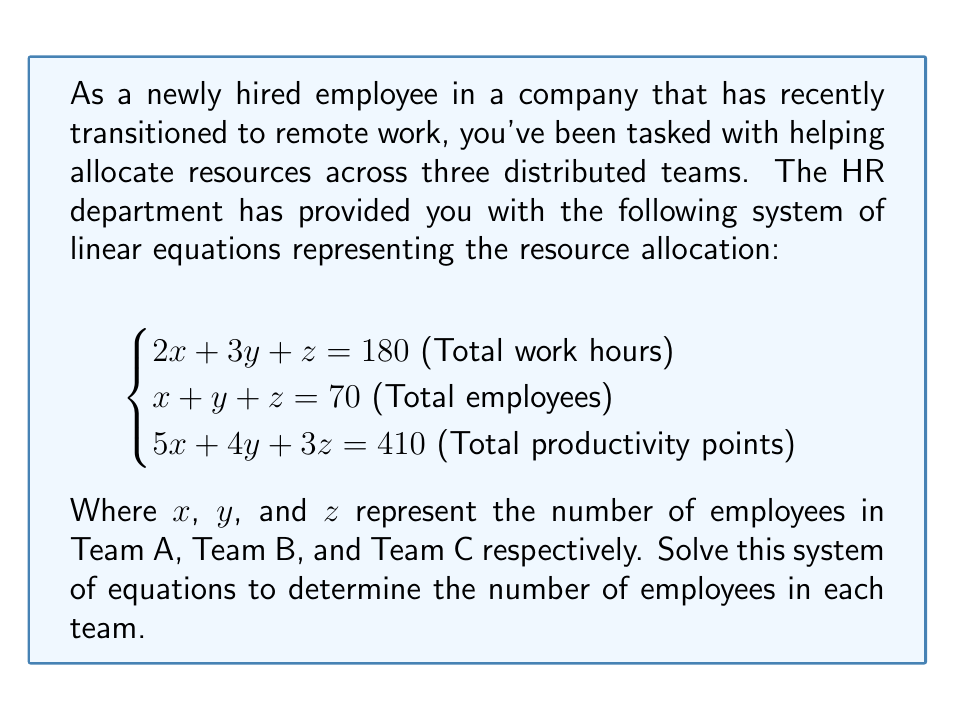Solve this math problem. To solve this system of linear equations, we'll use the Gaussian elimination method:

1) First, let's write the augmented matrix:

$$\begin{bmatrix}
2 & 3 & 1 & 180 \\
1 & 1 & 1 & 70 \\
5 & 4 & 3 & 410
\end{bmatrix}$$

2) Subtract row 2 from row 1:

$$\begin{bmatrix}
1 & 2 & 0 & 110 \\
1 & 1 & 1 & 70 \\
5 & 4 & 3 & 410
\end{bmatrix}$$

3) Subtract 5 times row 1 from row 3:

$$\begin{bmatrix}
1 & 2 & 0 & 110 \\
1 & 1 & 1 & 70 \\
0 & -6 & 3 & -140
\end{bmatrix}$$

4) Add row 1 to row 2:

$$\begin{bmatrix}
1 & 2 & 0 & 110 \\
0 & -1 & 1 & -40 \\
0 & -6 & 3 & -140
\end{bmatrix}$$

5) Add 6 times row 2 to row 3:

$$\begin{bmatrix}
1 & 2 & 0 & 110 \\
0 & -1 & 1 & -40 \\
0 & 0 & 9 & -380
\end{bmatrix}$$

6) Now we have an upper triangular matrix. Let's solve for z:

$9z = -380$
$z = -\frac{380}{9} \approx -42.22$

Since z represents the number of employees, it can't be negative or a fraction. This means our original assumption that there's a solution might be incorrect.

7) Let's check if there's a solution by row reducing further:

$$\begin{bmatrix}
1 & 2 & 0 & 110 \\
0 & 1 & -1 & 40 \\
0 & 0 & 1 & -\frac{380}{9}
\end{bmatrix}$$

8) Subtract row 3 from row 2:

$$\begin{bmatrix}
1 & 2 & 0 & 110 \\
0 & 1 & 0 & 40 + \frac{380}{9} \\
0 & 0 & 1 & -\frac{380}{9}
\end{bmatrix}$$

9) Subtract 2 times row 2 from row 1:

$$\begin{bmatrix}
1 & 0 & 0 & 110 - 2(40 + \frac{380}{9}) \\
0 & 1 & 0 & 40 + \frac{380}{9} \\
0 & 0 & 1 & -\frac{380}{9}
\end{bmatrix}$$

The last row gives us a contradiction: $z = -\frac{380}{9}$, which is not a valid number of employees.
Answer: The system of equations has no solution. This indicates that the given resource allocation constraints are inconsistent and cannot be satisfied simultaneously with integer values for the number of employees in each team. 